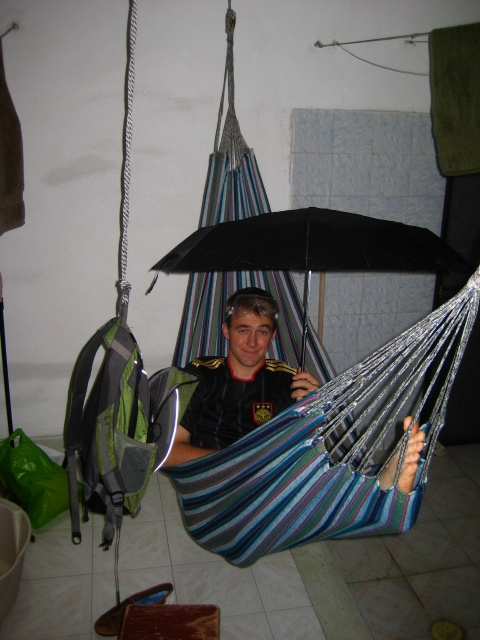What items can be seen hanging alongside the hammock? Alongside the hammock, there's a backpack and an umbrella hanging on the wall. The backpack is green and looks like it's meant for hiking, and the umbrella is large and black. 